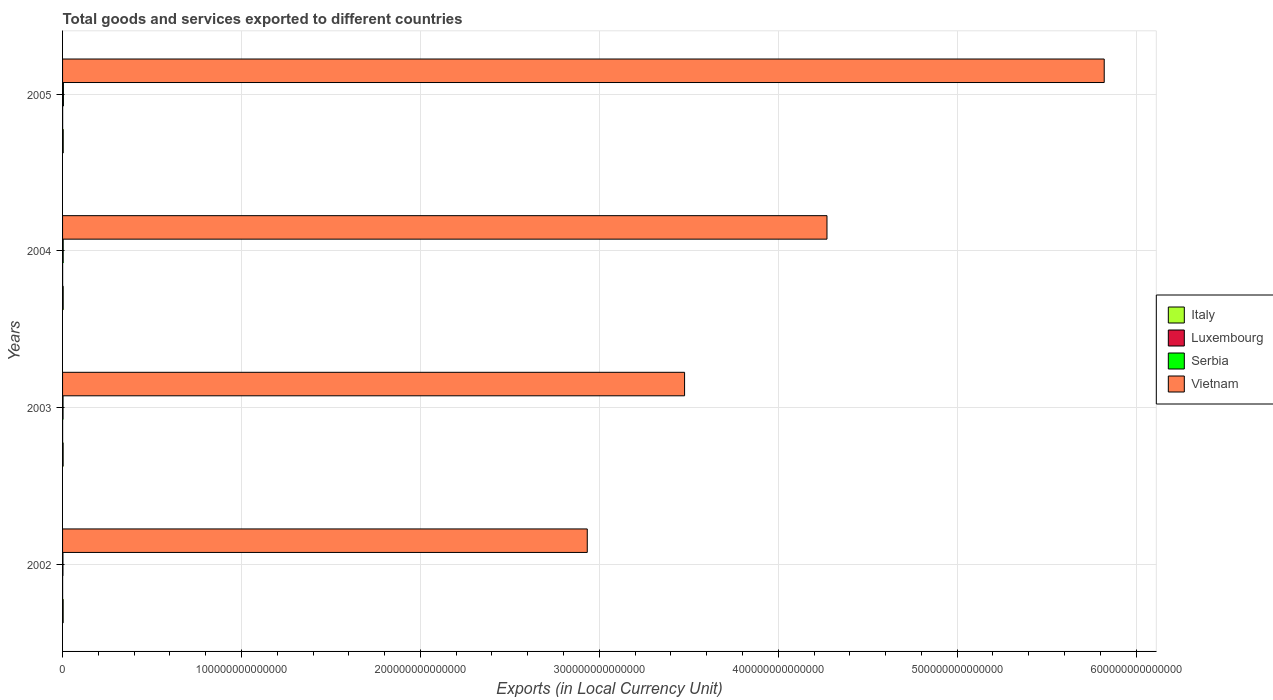How many bars are there on the 4th tick from the top?
Your answer should be very brief. 4. What is the label of the 4th group of bars from the top?
Provide a short and direct response. 2002. In how many cases, is the number of bars for a given year not equal to the number of legend labels?
Provide a short and direct response. 0. What is the Amount of goods and services exports in Italy in 2002?
Offer a very short reply. 3.29e+11. Across all years, what is the maximum Amount of goods and services exports in Italy?
Provide a short and direct response. 3.67e+11. Across all years, what is the minimum Amount of goods and services exports in Italy?
Offer a very short reply. 3.25e+11. What is the total Amount of goods and services exports in Italy in the graph?
Make the answer very short. 1.37e+12. What is the difference between the Amount of goods and services exports in Serbia in 2002 and that in 2004?
Offer a terse response. -1.37e+11. What is the difference between the Amount of goods and services exports in Serbia in 2005 and the Amount of goods and services exports in Italy in 2002?
Offer a very short reply. 1.46e+11. What is the average Amount of goods and services exports in Serbia per year?
Give a very brief answer. 3.27e+11. In the year 2005, what is the difference between the Amount of goods and services exports in Serbia and Amount of goods and services exports in Luxembourg?
Offer a terse response. 4.27e+11. What is the ratio of the Amount of goods and services exports in Italy in 2003 to that in 2005?
Keep it short and to the point. 0.88. Is the Amount of goods and services exports in Vietnam in 2002 less than that in 2005?
Provide a succinct answer. Yes. Is the difference between the Amount of goods and services exports in Serbia in 2004 and 2005 greater than the difference between the Amount of goods and services exports in Luxembourg in 2004 and 2005?
Your response must be concise. No. What is the difference between the highest and the second highest Amount of goods and services exports in Serbia?
Offer a terse response. 1.24e+11. What is the difference between the highest and the lowest Amount of goods and services exports in Vietnam?
Give a very brief answer. 2.89e+14. In how many years, is the Amount of goods and services exports in Vietnam greater than the average Amount of goods and services exports in Vietnam taken over all years?
Your answer should be compact. 2. Is the sum of the Amount of goods and services exports in Luxembourg in 2002 and 2004 greater than the maximum Amount of goods and services exports in Italy across all years?
Give a very brief answer. No. What does the 3rd bar from the top in 2002 represents?
Keep it short and to the point. Luxembourg. What does the 3rd bar from the bottom in 2002 represents?
Keep it short and to the point. Serbia. Is it the case that in every year, the sum of the Amount of goods and services exports in Luxembourg and Amount of goods and services exports in Serbia is greater than the Amount of goods and services exports in Vietnam?
Make the answer very short. No. How many bars are there?
Give a very brief answer. 16. What is the difference between two consecutive major ticks on the X-axis?
Your answer should be very brief. 1.00e+14. Are the values on the major ticks of X-axis written in scientific E-notation?
Give a very brief answer. No. Does the graph contain any zero values?
Keep it short and to the point. No. Does the graph contain grids?
Offer a very short reply. Yes. What is the title of the graph?
Offer a very short reply. Total goods and services exported to different countries. What is the label or title of the X-axis?
Make the answer very short. Exports (in Local Currency Unit). What is the Exports (in Local Currency Unit) of Italy in 2002?
Provide a short and direct response. 3.29e+11. What is the Exports (in Local Currency Unit) in Luxembourg in 2002?
Provide a succinct answer. 3.52e+1. What is the Exports (in Local Currency Unit) of Serbia in 2002?
Keep it short and to the point. 2.14e+11. What is the Exports (in Local Currency Unit) of Vietnam in 2002?
Your answer should be very brief. 2.93e+14. What is the Exports (in Local Currency Unit) in Italy in 2003?
Give a very brief answer. 3.25e+11. What is the Exports (in Local Currency Unit) in Luxembourg in 2003?
Ensure brevity in your answer.  3.61e+1. What is the Exports (in Local Currency Unit) in Serbia in 2003?
Your answer should be compact. 2.68e+11. What is the Exports (in Local Currency Unit) in Vietnam in 2003?
Make the answer very short. 3.48e+14. What is the Exports (in Local Currency Unit) in Italy in 2004?
Your answer should be compact. 3.49e+11. What is the Exports (in Local Currency Unit) of Luxembourg in 2004?
Make the answer very short. 4.22e+1. What is the Exports (in Local Currency Unit) in Serbia in 2004?
Give a very brief answer. 3.52e+11. What is the Exports (in Local Currency Unit) of Vietnam in 2004?
Provide a short and direct response. 4.27e+14. What is the Exports (in Local Currency Unit) in Italy in 2005?
Keep it short and to the point. 3.67e+11. What is the Exports (in Local Currency Unit) in Luxembourg in 2005?
Your answer should be compact. 4.79e+1. What is the Exports (in Local Currency Unit) in Serbia in 2005?
Your answer should be compact. 4.75e+11. What is the Exports (in Local Currency Unit) in Vietnam in 2005?
Offer a very short reply. 5.82e+14. Across all years, what is the maximum Exports (in Local Currency Unit) of Italy?
Ensure brevity in your answer.  3.67e+11. Across all years, what is the maximum Exports (in Local Currency Unit) in Luxembourg?
Provide a short and direct response. 4.79e+1. Across all years, what is the maximum Exports (in Local Currency Unit) in Serbia?
Offer a terse response. 4.75e+11. Across all years, what is the maximum Exports (in Local Currency Unit) of Vietnam?
Make the answer very short. 5.82e+14. Across all years, what is the minimum Exports (in Local Currency Unit) in Italy?
Keep it short and to the point. 3.25e+11. Across all years, what is the minimum Exports (in Local Currency Unit) in Luxembourg?
Your answer should be compact. 3.52e+1. Across all years, what is the minimum Exports (in Local Currency Unit) in Serbia?
Offer a terse response. 2.14e+11. Across all years, what is the minimum Exports (in Local Currency Unit) of Vietnam?
Give a very brief answer. 2.93e+14. What is the total Exports (in Local Currency Unit) of Italy in the graph?
Give a very brief answer. 1.37e+12. What is the total Exports (in Local Currency Unit) in Luxembourg in the graph?
Offer a terse response. 1.61e+11. What is the total Exports (in Local Currency Unit) of Serbia in the graph?
Offer a terse response. 1.31e+12. What is the total Exports (in Local Currency Unit) of Vietnam in the graph?
Provide a short and direct response. 1.65e+15. What is the difference between the Exports (in Local Currency Unit) of Italy in 2002 and that in 2003?
Keep it short and to the point. 4.47e+09. What is the difference between the Exports (in Local Currency Unit) of Luxembourg in 2002 and that in 2003?
Offer a very short reply. -9.14e+08. What is the difference between the Exports (in Local Currency Unit) in Serbia in 2002 and that in 2003?
Provide a short and direct response. -5.37e+1. What is the difference between the Exports (in Local Currency Unit) in Vietnam in 2002 and that in 2003?
Provide a succinct answer. -5.44e+13. What is the difference between the Exports (in Local Currency Unit) in Italy in 2002 and that in 2004?
Offer a terse response. -1.92e+1. What is the difference between the Exports (in Local Currency Unit) of Luxembourg in 2002 and that in 2004?
Your answer should be compact. -7.03e+09. What is the difference between the Exports (in Local Currency Unit) in Serbia in 2002 and that in 2004?
Your answer should be very brief. -1.37e+11. What is the difference between the Exports (in Local Currency Unit) in Vietnam in 2002 and that in 2004?
Provide a succinct answer. -1.34e+14. What is the difference between the Exports (in Local Currency Unit) of Italy in 2002 and that in 2005?
Offer a very short reply. -3.79e+1. What is the difference between the Exports (in Local Currency Unit) of Luxembourg in 2002 and that in 2005?
Offer a terse response. -1.27e+1. What is the difference between the Exports (in Local Currency Unit) in Serbia in 2002 and that in 2005?
Make the answer very short. -2.61e+11. What is the difference between the Exports (in Local Currency Unit) in Vietnam in 2002 and that in 2005?
Your answer should be very brief. -2.89e+14. What is the difference between the Exports (in Local Currency Unit) in Italy in 2003 and that in 2004?
Offer a very short reply. -2.36e+1. What is the difference between the Exports (in Local Currency Unit) of Luxembourg in 2003 and that in 2004?
Your answer should be compact. -6.12e+09. What is the difference between the Exports (in Local Currency Unit) of Serbia in 2003 and that in 2004?
Give a very brief answer. -8.36e+1. What is the difference between the Exports (in Local Currency Unit) of Vietnam in 2003 and that in 2004?
Provide a short and direct response. -7.96e+13. What is the difference between the Exports (in Local Currency Unit) in Italy in 2003 and that in 2005?
Provide a succinct answer. -4.24e+1. What is the difference between the Exports (in Local Currency Unit) in Luxembourg in 2003 and that in 2005?
Offer a terse response. -1.18e+1. What is the difference between the Exports (in Local Currency Unit) of Serbia in 2003 and that in 2005?
Offer a very short reply. -2.07e+11. What is the difference between the Exports (in Local Currency Unit) in Vietnam in 2003 and that in 2005?
Keep it short and to the point. -2.35e+14. What is the difference between the Exports (in Local Currency Unit) of Italy in 2004 and that in 2005?
Provide a succinct answer. -1.87e+1. What is the difference between the Exports (in Local Currency Unit) in Luxembourg in 2004 and that in 2005?
Give a very brief answer. -5.66e+09. What is the difference between the Exports (in Local Currency Unit) in Serbia in 2004 and that in 2005?
Offer a very short reply. -1.24e+11. What is the difference between the Exports (in Local Currency Unit) of Vietnam in 2004 and that in 2005?
Ensure brevity in your answer.  -1.55e+14. What is the difference between the Exports (in Local Currency Unit) in Italy in 2002 and the Exports (in Local Currency Unit) in Luxembourg in 2003?
Keep it short and to the point. 2.93e+11. What is the difference between the Exports (in Local Currency Unit) of Italy in 2002 and the Exports (in Local Currency Unit) of Serbia in 2003?
Provide a succinct answer. 6.14e+1. What is the difference between the Exports (in Local Currency Unit) in Italy in 2002 and the Exports (in Local Currency Unit) in Vietnam in 2003?
Offer a terse response. -3.47e+14. What is the difference between the Exports (in Local Currency Unit) of Luxembourg in 2002 and the Exports (in Local Currency Unit) of Serbia in 2003?
Provide a short and direct response. -2.33e+11. What is the difference between the Exports (in Local Currency Unit) in Luxembourg in 2002 and the Exports (in Local Currency Unit) in Vietnam in 2003?
Your response must be concise. -3.48e+14. What is the difference between the Exports (in Local Currency Unit) of Serbia in 2002 and the Exports (in Local Currency Unit) of Vietnam in 2003?
Your answer should be compact. -3.47e+14. What is the difference between the Exports (in Local Currency Unit) in Italy in 2002 and the Exports (in Local Currency Unit) in Luxembourg in 2004?
Make the answer very short. 2.87e+11. What is the difference between the Exports (in Local Currency Unit) in Italy in 2002 and the Exports (in Local Currency Unit) in Serbia in 2004?
Keep it short and to the point. -2.22e+1. What is the difference between the Exports (in Local Currency Unit) of Italy in 2002 and the Exports (in Local Currency Unit) of Vietnam in 2004?
Your answer should be compact. -4.27e+14. What is the difference between the Exports (in Local Currency Unit) in Luxembourg in 2002 and the Exports (in Local Currency Unit) in Serbia in 2004?
Offer a very short reply. -3.16e+11. What is the difference between the Exports (in Local Currency Unit) of Luxembourg in 2002 and the Exports (in Local Currency Unit) of Vietnam in 2004?
Provide a short and direct response. -4.27e+14. What is the difference between the Exports (in Local Currency Unit) in Serbia in 2002 and the Exports (in Local Currency Unit) in Vietnam in 2004?
Your answer should be compact. -4.27e+14. What is the difference between the Exports (in Local Currency Unit) in Italy in 2002 and the Exports (in Local Currency Unit) in Luxembourg in 2005?
Offer a very short reply. 2.81e+11. What is the difference between the Exports (in Local Currency Unit) of Italy in 2002 and the Exports (in Local Currency Unit) of Serbia in 2005?
Your answer should be compact. -1.46e+11. What is the difference between the Exports (in Local Currency Unit) in Italy in 2002 and the Exports (in Local Currency Unit) in Vietnam in 2005?
Your response must be concise. -5.82e+14. What is the difference between the Exports (in Local Currency Unit) of Luxembourg in 2002 and the Exports (in Local Currency Unit) of Serbia in 2005?
Provide a short and direct response. -4.40e+11. What is the difference between the Exports (in Local Currency Unit) in Luxembourg in 2002 and the Exports (in Local Currency Unit) in Vietnam in 2005?
Provide a succinct answer. -5.82e+14. What is the difference between the Exports (in Local Currency Unit) of Serbia in 2002 and the Exports (in Local Currency Unit) of Vietnam in 2005?
Provide a short and direct response. -5.82e+14. What is the difference between the Exports (in Local Currency Unit) in Italy in 2003 and the Exports (in Local Currency Unit) in Luxembourg in 2004?
Provide a short and direct response. 2.83e+11. What is the difference between the Exports (in Local Currency Unit) in Italy in 2003 and the Exports (in Local Currency Unit) in Serbia in 2004?
Give a very brief answer. -2.67e+1. What is the difference between the Exports (in Local Currency Unit) in Italy in 2003 and the Exports (in Local Currency Unit) in Vietnam in 2004?
Keep it short and to the point. -4.27e+14. What is the difference between the Exports (in Local Currency Unit) in Luxembourg in 2003 and the Exports (in Local Currency Unit) in Serbia in 2004?
Ensure brevity in your answer.  -3.15e+11. What is the difference between the Exports (in Local Currency Unit) of Luxembourg in 2003 and the Exports (in Local Currency Unit) of Vietnam in 2004?
Keep it short and to the point. -4.27e+14. What is the difference between the Exports (in Local Currency Unit) in Serbia in 2003 and the Exports (in Local Currency Unit) in Vietnam in 2004?
Ensure brevity in your answer.  -4.27e+14. What is the difference between the Exports (in Local Currency Unit) of Italy in 2003 and the Exports (in Local Currency Unit) of Luxembourg in 2005?
Ensure brevity in your answer.  2.77e+11. What is the difference between the Exports (in Local Currency Unit) in Italy in 2003 and the Exports (in Local Currency Unit) in Serbia in 2005?
Your answer should be very brief. -1.50e+11. What is the difference between the Exports (in Local Currency Unit) of Italy in 2003 and the Exports (in Local Currency Unit) of Vietnam in 2005?
Provide a succinct answer. -5.82e+14. What is the difference between the Exports (in Local Currency Unit) in Luxembourg in 2003 and the Exports (in Local Currency Unit) in Serbia in 2005?
Your answer should be very brief. -4.39e+11. What is the difference between the Exports (in Local Currency Unit) of Luxembourg in 2003 and the Exports (in Local Currency Unit) of Vietnam in 2005?
Offer a terse response. -5.82e+14. What is the difference between the Exports (in Local Currency Unit) in Serbia in 2003 and the Exports (in Local Currency Unit) in Vietnam in 2005?
Make the answer very short. -5.82e+14. What is the difference between the Exports (in Local Currency Unit) in Italy in 2004 and the Exports (in Local Currency Unit) in Luxembourg in 2005?
Your response must be concise. 3.01e+11. What is the difference between the Exports (in Local Currency Unit) in Italy in 2004 and the Exports (in Local Currency Unit) in Serbia in 2005?
Provide a succinct answer. -1.27e+11. What is the difference between the Exports (in Local Currency Unit) of Italy in 2004 and the Exports (in Local Currency Unit) of Vietnam in 2005?
Offer a terse response. -5.82e+14. What is the difference between the Exports (in Local Currency Unit) in Luxembourg in 2004 and the Exports (in Local Currency Unit) in Serbia in 2005?
Your answer should be very brief. -4.33e+11. What is the difference between the Exports (in Local Currency Unit) in Luxembourg in 2004 and the Exports (in Local Currency Unit) in Vietnam in 2005?
Your answer should be compact. -5.82e+14. What is the difference between the Exports (in Local Currency Unit) in Serbia in 2004 and the Exports (in Local Currency Unit) in Vietnam in 2005?
Offer a terse response. -5.82e+14. What is the average Exports (in Local Currency Unit) of Italy per year?
Keep it short and to the point. 3.42e+11. What is the average Exports (in Local Currency Unit) of Luxembourg per year?
Your answer should be compact. 4.04e+1. What is the average Exports (in Local Currency Unit) of Serbia per year?
Give a very brief answer. 3.27e+11. What is the average Exports (in Local Currency Unit) of Vietnam per year?
Your answer should be compact. 4.13e+14. In the year 2002, what is the difference between the Exports (in Local Currency Unit) in Italy and Exports (in Local Currency Unit) in Luxembourg?
Ensure brevity in your answer.  2.94e+11. In the year 2002, what is the difference between the Exports (in Local Currency Unit) in Italy and Exports (in Local Currency Unit) in Serbia?
Provide a succinct answer. 1.15e+11. In the year 2002, what is the difference between the Exports (in Local Currency Unit) in Italy and Exports (in Local Currency Unit) in Vietnam?
Ensure brevity in your answer.  -2.93e+14. In the year 2002, what is the difference between the Exports (in Local Currency Unit) in Luxembourg and Exports (in Local Currency Unit) in Serbia?
Offer a terse response. -1.79e+11. In the year 2002, what is the difference between the Exports (in Local Currency Unit) in Luxembourg and Exports (in Local Currency Unit) in Vietnam?
Offer a very short reply. -2.93e+14. In the year 2002, what is the difference between the Exports (in Local Currency Unit) in Serbia and Exports (in Local Currency Unit) in Vietnam?
Your response must be concise. -2.93e+14. In the year 2003, what is the difference between the Exports (in Local Currency Unit) of Italy and Exports (in Local Currency Unit) of Luxembourg?
Provide a short and direct response. 2.89e+11. In the year 2003, what is the difference between the Exports (in Local Currency Unit) in Italy and Exports (in Local Currency Unit) in Serbia?
Provide a short and direct response. 5.69e+1. In the year 2003, what is the difference between the Exports (in Local Currency Unit) of Italy and Exports (in Local Currency Unit) of Vietnam?
Your answer should be very brief. -3.47e+14. In the year 2003, what is the difference between the Exports (in Local Currency Unit) of Luxembourg and Exports (in Local Currency Unit) of Serbia?
Provide a succinct answer. -2.32e+11. In the year 2003, what is the difference between the Exports (in Local Currency Unit) in Luxembourg and Exports (in Local Currency Unit) in Vietnam?
Provide a succinct answer. -3.48e+14. In the year 2003, what is the difference between the Exports (in Local Currency Unit) of Serbia and Exports (in Local Currency Unit) of Vietnam?
Offer a very short reply. -3.47e+14. In the year 2004, what is the difference between the Exports (in Local Currency Unit) in Italy and Exports (in Local Currency Unit) in Luxembourg?
Keep it short and to the point. 3.06e+11. In the year 2004, what is the difference between the Exports (in Local Currency Unit) in Italy and Exports (in Local Currency Unit) in Serbia?
Your answer should be compact. -3.01e+09. In the year 2004, what is the difference between the Exports (in Local Currency Unit) of Italy and Exports (in Local Currency Unit) of Vietnam?
Ensure brevity in your answer.  -4.27e+14. In the year 2004, what is the difference between the Exports (in Local Currency Unit) in Luxembourg and Exports (in Local Currency Unit) in Serbia?
Ensure brevity in your answer.  -3.09e+11. In the year 2004, what is the difference between the Exports (in Local Currency Unit) of Luxembourg and Exports (in Local Currency Unit) of Vietnam?
Ensure brevity in your answer.  -4.27e+14. In the year 2004, what is the difference between the Exports (in Local Currency Unit) of Serbia and Exports (in Local Currency Unit) of Vietnam?
Offer a terse response. -4.27e+14. In the year 2005, what is the difference between the Exports (in Local Currency Unit) in Italy and Exports (in Local Currency Unit) in Luxembourg?
Give a very brief answer. 3.19e+11. In the year 2005, what is the difference between the Exports (in Local Currency Unit) of Italy and Exports (in Local Currency Unit) of Serbia?
Offer a very short reply. -1.08e+11. In the year 2005, what is the difference between the Exports (in Local Currency Unit) in Italy and Exports (in Local Currency Unit) in Vietnam?
Make the answer very short. -5.82e+14. In the year 2005, what is the difference between the Exports (in Local Currency Unit) in Luxembourg and Exports (in Local Currency Unit) in Serbia?
Make the answer very short. -4.27e+11. In the year 2005, what is the difference between the Exports (in Local Currency Unit) of Luxembourg and Exports (in Local Currency Unit) of Vietnam?
Offer a terse response. -5.82e+14. In the year 2005, what is the difference between the Exports (in Local Currency Unit) of Serbia and Exports (in Local Currency Unit) of Vietnam?
Your answer should be very brief. -5.82e+14. What is the ratio of the Exports (in Local Currency Unit) of Italy in 2002 to that in 2003?
Your answer should be compact. 1.01. What is the ratio of the Exports (in Local Currency Unit) in Luxembourg in 2002 to that in 2003?
Provide a short and direct response. 0.97. What is the ratio of the Exports (in Local Currency Unit) of Serbia in 2002 to that in 2003?
Your answer should be compact. 0.8. What is the ratio of the Exports (in Local Currency Unit) in Vietnam in 2002 to that in 2003?
Your response must be concise. 0.84. What is the ratio of the Exports (in Local Currency Unit) of Italy in 2002 to that in 2004?
Your answer should be compact. 0.94. What is the ratio of the Exports (in Local Currency Unit) in Luxembourg in 2002 to that in 2004?
Your response must be concise. 0.83. What is the ratio of the Exports (in Local Currency Unit) in Serbia in 2002 to that in 2004?
Make the answer very short. 0.61. What is the ratio of the Exports (in Local Currency Unit) of Vietnam in 2002 to that in 2004?
Provide a short and direct response. 0.69. What is the ratio of the Exports (in Local Currency Unit) in Italy in 2002 to that in 2005?
Your answer should be very brief. 0.9. What is the ratio of the Exports (in Local Currency Unit) in Luxembourg in 2002 to that in 2005?
Provide a short and direct response. 0.74. What is the ratio of the Exports (in Local Currency Unit) in Serbia in 2002 to that in 2005?
Your response must be concise. 0.45. What is the ratio of the Exports (in Local Currency Unit) of Vietnam in 2002 to that in 2005?
Keep it short and to the point. 0.5. What is the ratio of the Exports (in Local Currency Unit) of Italy in 2003 to that in 2004?
Your answer should be compact. 0.93. What is the ratio of the Exports (in Local Currency Unit) of Luxembourg in 2003 to that in 2004?
Provide a succinct answer. 0.86. What is the ratio of the Exports (in Local Currency Unit) of Serbia in 2003 to that in 2004?
Give a very brief answer. 0.76. What is the ratio of the Exports (in Local Currency Unit) of Vietnam in 2003 to that in 2004?
Keep it short and to the point. 0.81. What is the ratio of the Exports (in Local Currency Unit) in Italy in 2003 to that in 2005?
Your response must be concise. 0.88. What is the ratio of the Exports (in Local Currency Unit) in Luxembourg in 2003 to that in 2005?
Your answer should be very brief. 0.75. What is the ratio of the Exports (in Local Currency Unit) in Serbia in 2003 to that in 2005?
Offer a terse response. 0.56. What is the ratio of the Exports (in Local Currency Unit) of Vietnam in 2003 to that in 2005?
Offer a terse response. 0.6. What is the ratio of the Exports (in Local Currency Unit) in Italy in 2004 to that in 2005?
Your answer should be compact. 0.95. What is the ratio of the Exports (in Local Currency Unit) of Luxembourg in 2004 to that in 2005?
Make the answer very short. 0.88. What is the ratio of the Exports (in Local Currency Unit) in Serbia in 2004 to that in 2005?
Offer a very short reply. 0.74. What is the ratio of the Exports (in Local Currency Unit) of Vietnam in 2004 to that in 2005?
Give a very brief answer. 0.73. What is the difference between the highest and the second highest Exports (in Local Currency Unit) in Italy?
Keep it short and to the point. 1.87e+1. What is the difference between the highest and the second highest Exports (in Local Currency Unit) in Luxembourg?
Give a very brief answer. 5.66e+09. What is the difference between the highest and the second highest Exports (in Local Currency Unit) of Serbia?
Your answer should be compact. 1.24e+11. What is the difference between the highest and the second highest Exports (in Local Currency Unit) in Vietnam?
Offer a very short reply. 1.55e+14. What is the difference between the highest and the lowest Exports (in Local Currency Unit) of Italy?
Your answer should be very brief. 4.24e+1. What is the difference between the highest and the lowest Exports (in Local Currency Unit) of Luxembourg?
Your answer should be very brief. 1.27e+1. What is the difference between the highest and the lowest Exports (in Local Currency Unit) in Serbia?
Provide a short and direct response. 2.61e+11. What is the difference between the highest and the lowest Exports (in Local Currency Unit) in Vietnam?
Make the answer very short. 2.89e+14. 